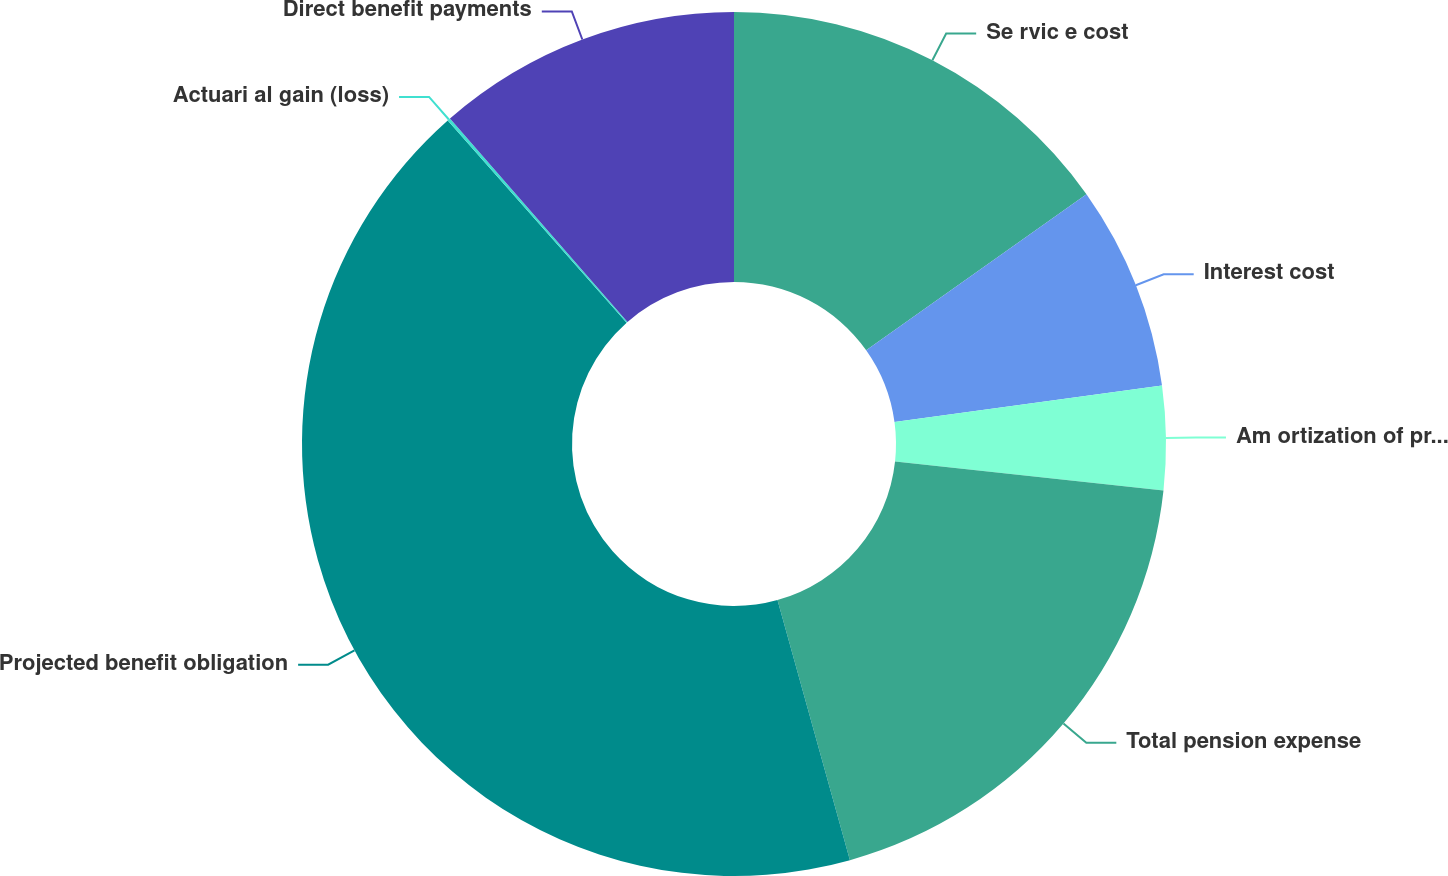<chart> <loc_0><loc_0><loc_500><loc_500><pie_chart><fcel>Se rvic e cost<fcel>Interest cost<fcel>Am ortization of prior service<fcel>Total pension expense<fcel>Projected benefit obligation<fcel>Actuari al gain (loss)<fcel>Direct benefit payments<nl><fcel>15.19%<fcel>7.65%<fcel>3.88%<fcel>18.96%<fcel>42.8%<fcel>0.11%<fcel>11.42%<nl></chart> 